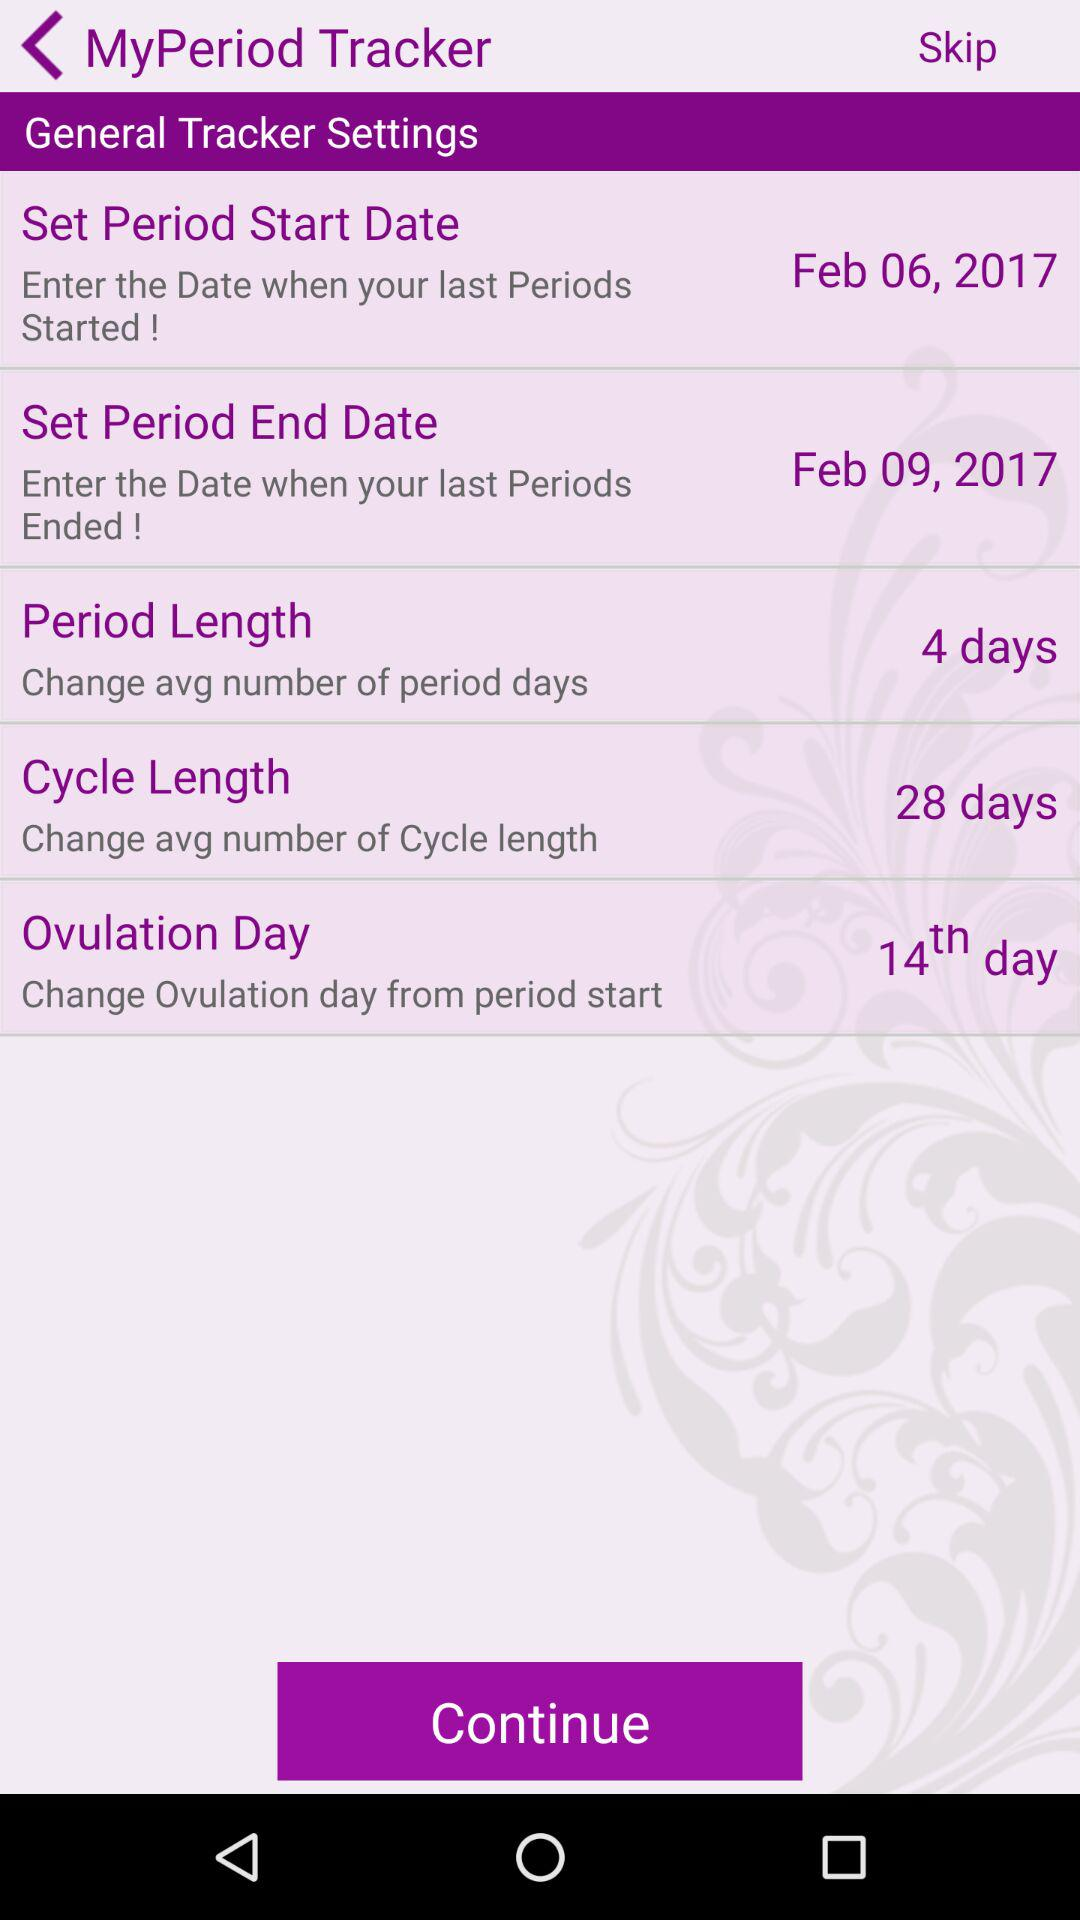On what day will ovulation occur? Ovulation will occur on the 14th day. 